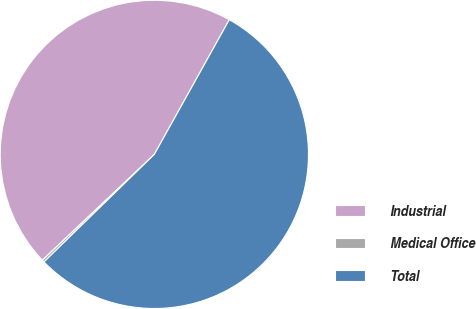Convert chart to OTSL. <chart><loc_0><loc_0><loc_500><loc_500><pie_chart><fcel>Industrial<fcel>Medical Office<fcel>Total<nl><fcel>45.13%<fcel>0.25%<fcel>54.62%<nl></chart> 